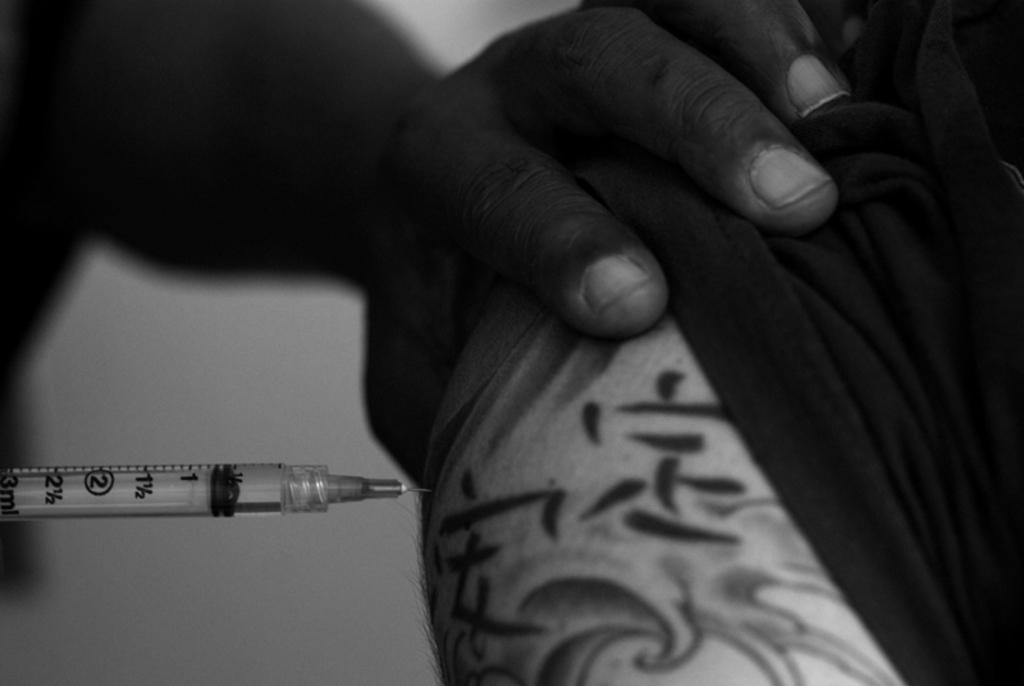What is the person in the image holding? The person is holding an injection. What is the person doing with the injection? The person is injecting liquid into another person's vein. Can you describe any other objects in the image? There are other unspecified objects in the image. How many flies can be seen on the person's hand in the image? There are no flies present in the image. Is the person wearing a glove while performing the injection? There is no mention of a glove in the image, so it cannot be determined whether the person is wearing one or not. 